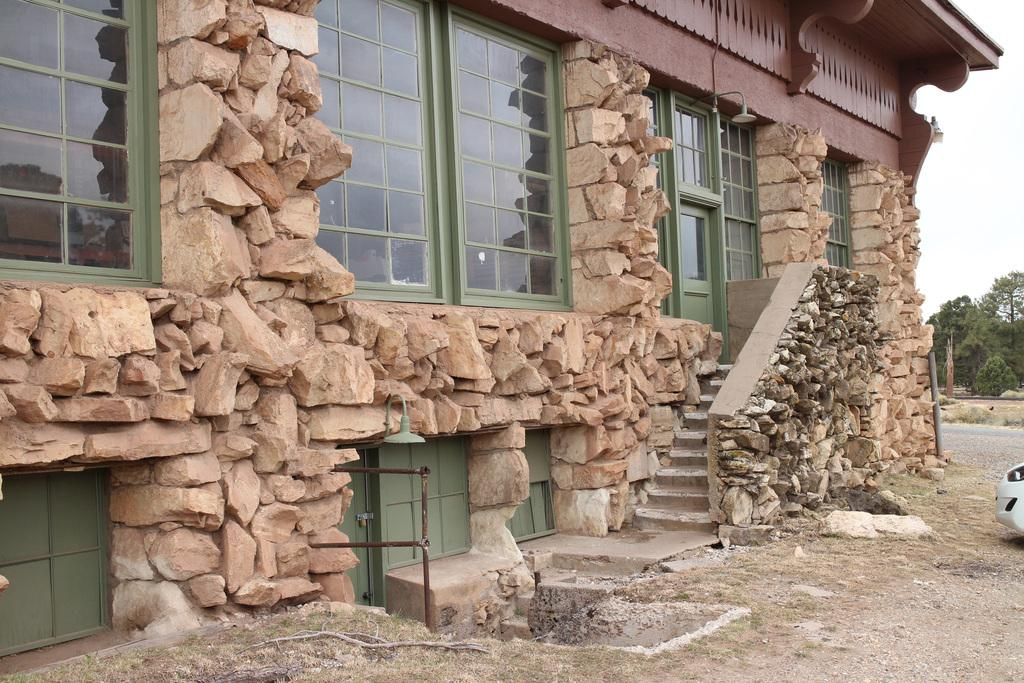What type of structure is present in the image? There is a building with windows in the image. What natural elements can be seen in the image? There are rocks and a group of trees in the image. What man-made objects are visible in the image? Metal poles and a vehicle are visible in the image. What part of the natural environment is visible in the image? The sky is visible in the image. What type of string is being used to hold the house in the image? There is no house present in the image, and therefore no string is being used to hold it. What is the edge of the image used for in the scene? The edge of the image is not part of the scene; it is simply the boundary of the photograph. 